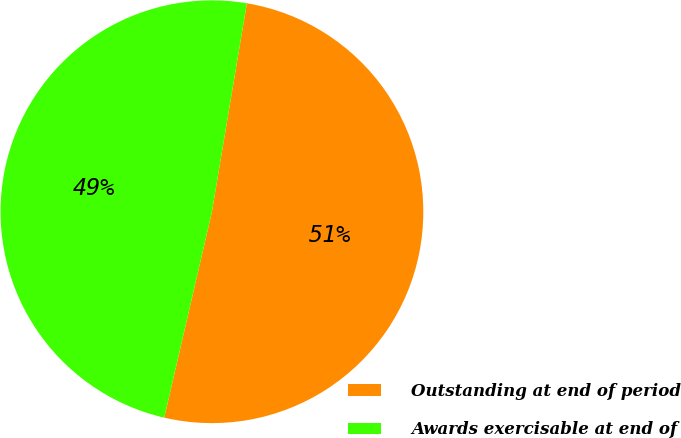<chart> <loc_0><loc_0><loc_500><loc_500><pie_chart><fcel>Outstanding at end of period<fcel>Awards exercisable at end of<nl><fcel>50.98%<fcel>49.02%<nl></chart> 